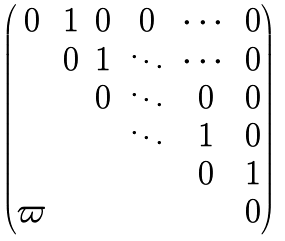Convert formula to latex. <formula><loc_0><loc_0><loc_500><loc_500>\begin{pmatrix} 0 & 1 & 0 & 0 & \cdots & 0 \\ & 0 & 1 & \ddots & \cdots & 0 \\ & & 0 & \ddots & 0 & 0 \\ & & & \ddots & 1 & 0 \\ & & & & 0 & 1 \\ \varpi & & & & & 0 \end{pmatrix}</formula> 